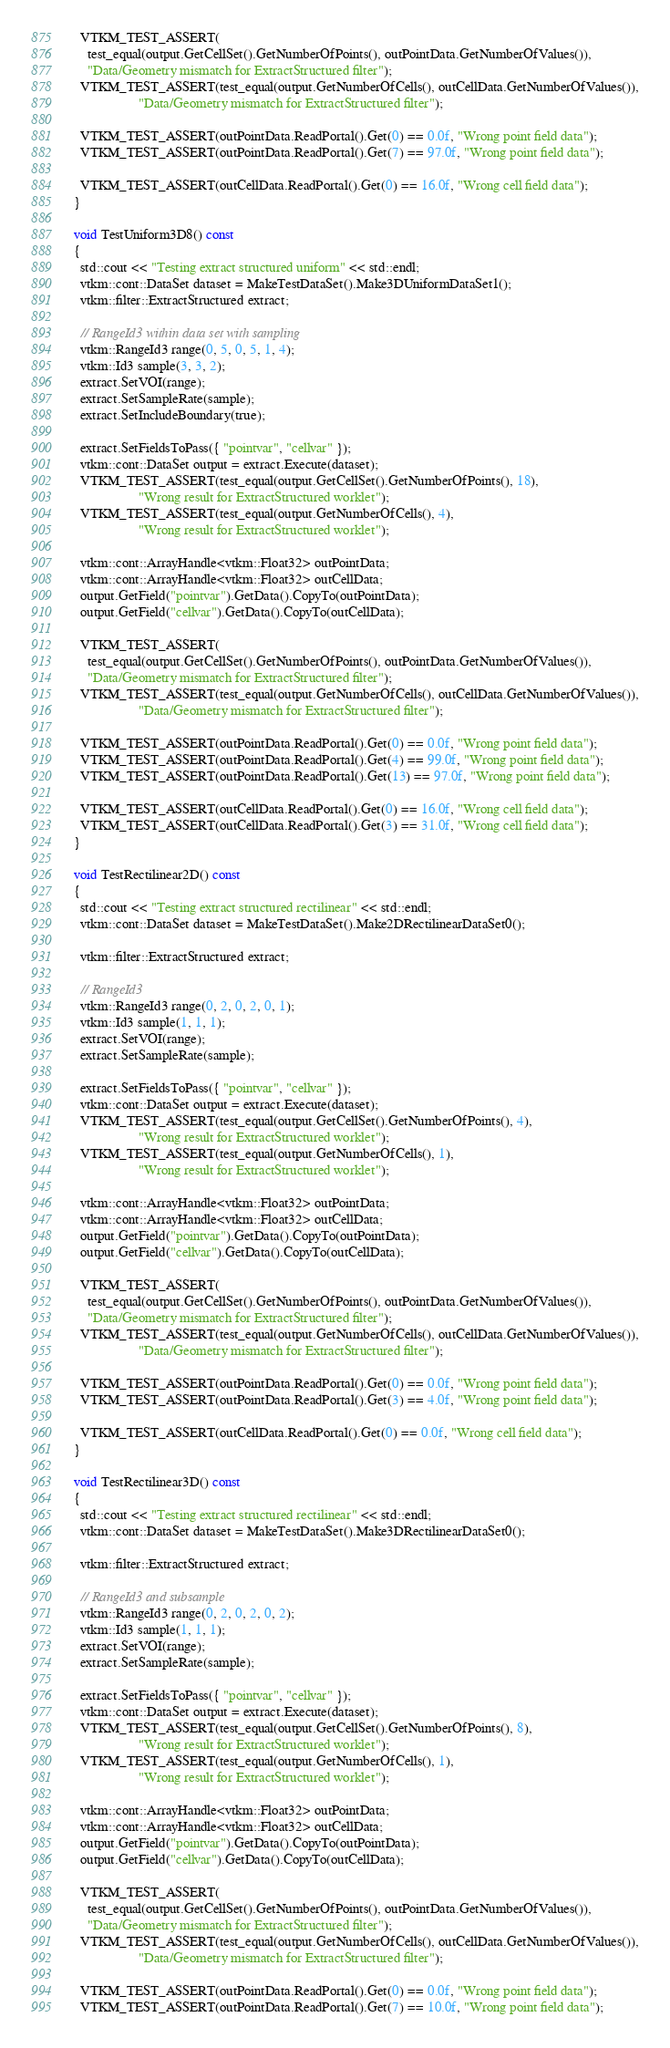<code> <loc_0><loc_0><loc_500><loc_500><_C++_>
    VTKM_TEST_ASSERT(
      test_equal(output.GetCellSet().GetNumberOfPoints(), outPointData.GetNumberOfValues()),
      "Data/Geometry mismatch for ExtractStructured filter");
    VTKM_TEST_ASSERT(test_equal(output.GetNumberOfCells(), outCellData.GetNumberOfValues()),
                     "Data/Geometry mismatch for ExtractStructured filter");

    VTKM_TEST_ASSERT(outPointData.ReadPortal().Get(0) == 0.0f, "Wrong point field data");
    VTKM_TEST_ASSERT(outPointData.ReadPortal().Get(7) == 97.0f, "Wrong point field data");

    VTKM_TEST_ASSERT(outCellData.ReadPortal().Get(0) == 16.0f, "Wrong cell field data");
  }

  void TestUniform3D8() const
  {
    std::cout << "Testing extract structured uniform" << std::endl;
    vtkm::cont::DataSet dataset = MakeTestDataSet().Make3DUniformDataSet1();
    vtkm::filter::ExtractStructured extract;

    // RangeId3 within data set with sampling
    vtkm::RangeId3 range(0, 5, 0, 5, 1, 4);
    vtkm::Id3 sample(3, 3, 2);
    extract.SetVOI(range);
    extract.SetSampleRate(sample);
    extract.SetIncludeBoundary(true);

    extract.SetFieldsToPass({ "pointvar", "cellvar" });
    vtkm::cont::DataSet output = extract.Execute(dataset);
    VTKM_TEST_ASSERT(test_equal(output.GetCellSet().GetNumberOfPoints(), 18),
                     "Wrong result for ExtractStructured worklet");
    VTKM_TEST_ASSERT(test_equal(output.GetNumberOfCells(), 4),
                     "Wrong result for ExtractStructured worklet");

    vtkm::cont::ArrayHandle<vtkm::Float32> outPointData;
    vtkm::cont::ArrayHandle<vtkm::Float32> outCellData;
    output.GetField("pointvar").GetData().CopyTo(outPointData);
    output.GetField("cellvar").GetData().CopyTo(outCellData);

    VTKM_TEST_ASSERT(
      test_equal(output.GetCellSet().GetNumberOfPoints(), outPointData.GetNumberOfValues()),
      "Data/Geometry mismatch for ExtractStructured filter");
    VTKM_TEST_ASSERT(test_equal(output.GetNumberOfCells(), outCellData.GetNumberOfValues()),
                     "Data/Geometry mismatch for ExtractStructured filter");

    VTKM_TEST_ASSERT(outPointData.ReadPortal().Get(0) == 0.0f, "Wrong point field data");
    VTKM_TEST_ASSERT(outPointData.ReadPortal().Get(4) == 99.0f, "Wrong point field data");
    VTKM_TEST_ASSERT(outPointData.ReadPortal().Get(13) == 97.0f, "Wrong point field data");

    VTKM_TEST_ASSERT(outCellData.ReadPortal().Get(0) == 16.0f, "Wrong cell field data");
    VTKM_TEST_ASSERT(outCellData.ReadPortal().Get(3) == 31.0f, "Wrong cell field data");
  }

  void TestRectilinear2D() const
  {
    std::cout << "Testing extract structured rectilinear" << std::endl;
    vtkm::cont::DataSet dataset = MakeTestDataSet().Make2DRectilinearDataSet0();

    vtkm::filter::ExtractStructured extract;

    // RangeId3
    vtkm::RangeId3 range(0, 2, 0, 2, 0, 1);
    vtkm::Id3 sample(1, 1, 1);
    extract.SetVOI(range);
    extract.SetSampleRate(sample);

    extract.SetFieldsToPass({ "pointvar", "cellvar" });
    vtkm::cont::DataSet output = extract.Execute(dataset);
    VTKM_TEST_ASSERT(test_equal(output.GetCellSet().GetNumberOfPoints(), 4),
                     "Wrong result for ExtractStructured worklet");
    VTKM_TEST_ASSERT(test_equal(output.GetNumberOfCells(), 1),
                     "Wrong result for ExtractStructured worklet");

    vtkm::cont::ArrayHandle<vtkm::Float32> outPointData;
    vtkm::cont::ArrayHandle<vtkm::Float32> outCellData;
    output.GetField("pointvar").GetData().CopyTo(outPointData);
    output.GetField("cellvar").GetData().CopyTo(outCellData);

    VTKM_TEST_ASSERT(
      test_equal(output.GetCellSet().GetNumberOfPoints(), outPointData.GetNumberOfValues()),
      "Data/Geometry mismatch for ExtractStructured filter");
    VTKM_TEST_ASSERT(test_equal(output.GetNumberOfCells(), outCellData.GetNumberOfValues()),
                     "Data/Geometry mismatch for ExtractStructured filter");

    VTKM_TEST_ASSERT(outPointData.ReadPortal().Get(0) == 0.0f, "Wrong point field data");
    VTKM_TEST_ASSERT(outPointData.ReadPortal().Get(3) == 4.0f, "Wrong point field data");

    VTKM_TEST_ASSERT(outCellData.ReadPortal().Get(0) == 0.0f, "Wrong cell field data");
  }

  void TestRectilinear3D() const
  {
    std::cout << "Testing extract structured rectilinear" << std::endl;
    vtkm::cont::DataSet dataset = MakeTestDataSet().Make3DRectilinearDataSet0();

    vtkm::filter::ExtractStructured extract;

    // RangeId3 and subsample
    vtkm::RangeId3 range(0, 2, 0, 2, 0, 2);
    vtkm::Id3 sample(1, 1, 1);
    extract.SetVOI(range);
    extract.SetSampleRate(sample);

    extract.SetFieldsToPass({ "pointvar", "cellvar" });
    vtkm::cont::DataSet output = extract.Execute(dataset);
    VTKM_TEST_ASSERT(test_equal(output.GetCellSet().GetNumberOfPoints(), 8),
                     "Wrong result for ExtractStructured worklet");
    VTKM_TEST_ASSERT(test_equal(output.GetNumberOfCells(), 1),
                     "Wrong result for ExtractStructured worklet");

    vtkm::cont::ArrayHandle<vtkm::Float32> outPointData;
    vtkm::cont::ArrayHandle<vtkm::Float32> outCellData;
    output.GetField("pointvar").GetData().CopyTo(outPointData);
    output.GetField("cellvar").GetData().CopyTo(outCellData);

    VTKM_TEST_ASSERT(
      test_equal(output.GetCellSet().GetNumberOfPoints(), outPointData.GetNumberOfValues()),
      "Data/Geometry mismatch for ExtractStructured filter");
    VTKM_TEST_ASSERT(test_equal(output.GetNumberOfCells(), outCellData.GetNumberOfValues()),
                     "Data/Geometry mismatch for ExtractStructured filter");

    VTKM_TEST_ASSERT(outPointData.ReadPortal().Get(0) == 0.0f, "Wrong point field data");
    VTKM_TEST_ASSERT(outPointData.ReadPortal().Get(7) == 10.0f, "Wrong point field data");
</code> 